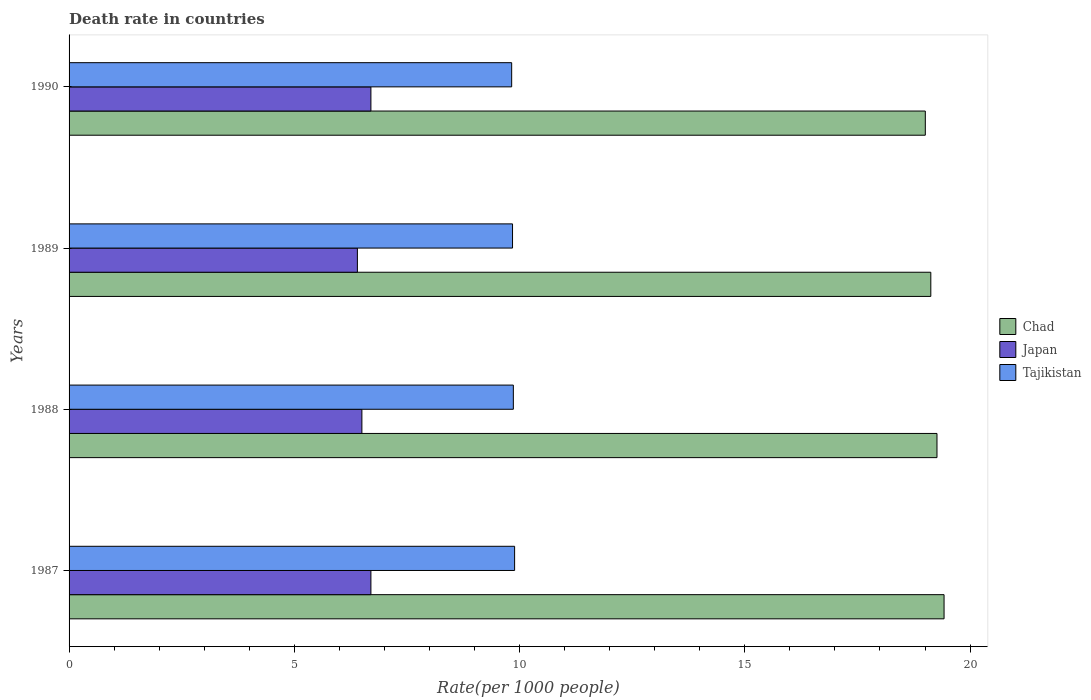How many different coloured bars are there?
Your response must be concise. 3. Are the number of bars on each tick of the Y-axis equal?
Keep it short and to the point. Yes. How many bars are there on the 4th tick from the top?
Make the answer very short. 3. How many bars are there on the 2nd tick from the bottom?
Ensure brevity in your answer.  3. What is the death rate in Tajikistan in 1990?
Make the answer very short. 9.82. Across all years, what is the maximum death rate in Tajikistan?
Your answer should be very brief. 9.89. What is the total death rate in Tajikistan in the graph?
Provide a succinct answer. 39.42. What is the difference between the death rate in Japan in 1988 and that in 1989?
Make the answer very short. 0.1. What is the difference between the death rate in Japan in 1990 and the death rate in Chad in 1989?
Your answer should be very brief. -12.43. What is the average death rate in Japan per year?
Make the answer very short. 6.58. In the year 1988, what is the difference between the death rate in Japan and death rate in Tajikistan?
Ensure brevity in your answer.  -3.36. In how many years, is the death rate in Japan greater than 15 ?
Provide a succinct answer. 0. What is the ratio of the death rate in Japan in 1988 to that in 1990?
Provide a short and direct response. 0.97. Is the difference between the death rate in Japan in 1987 and 1988 greater than the difference between the death rate in Tajikistan in 1987 and 1988?
Your answer should be very brief. Yes. What is the difference between the highest and the second highest death rate in Chad?
Your answer should be compact. 0.16. What is the difference between the highest and the lowest death rate in Tajikistan?
Keep it short and to the point. 0.07. Is the sum of the death rate in Tajikistan in 1987 and 1990 greater than the maximum death rate in Japan across all years?
Provide a short and direct response. Yes. What does the 1st bar from the bottom in 1990 represents?
Provide a succinct answer. Chad. How many bars are there?
Your answer should be compact. 12. Are all the bars in the graph horizontal?
Offer a terse response. Yes. Are the values on the major ticks of X-axis written in scientific E-notation?
Your answer should be compact. No. Does the graph contain any zero values?
Keep it short and to the point. No. Where does the legend appear in the graph?
Your response must be concise. Center right. What is the title of the graph?
Offer a very short reply. Death rate in countries. What is the label or title of the X-axis?
Give a very brief answer. Rate(per 1000 people). What is the Rate(per 1000 people) in Chad in 1987?
Provide a short and direct response. 19.42. What is the Rate(per 1000 people) in Tajikistan in 1987?
Offer a terse response. 9.89. What is the Rate(per 1000 people) of Chad in 1988?
Offer a very short reply. 19.27. What is the Rate(per 1000 people) of Japan in 1988?
Provide a succinct answer. 6.5. What is the Rate(per 1000 people) in Tajikistan in 1988?
Your answer should be compact. 9.86. What is the Rate(per 1000 people) of Chad in 1989?
Provide a short and direct response. 19.13. What is the Rate(per 1000 people) of Tajikistan in 1989?
Your answer should be very brief. 9.84. What is the Rate(per 1000 people) of Chad in 1990?
Make the answer very short. 19.01. What is the Rate(per 1000 people) of Japan in 1990?
Make the answer very short. 6.7. What is the Rate(per 1000 people) of Tajikistan in 1990?
Keep it short and to the point. 9.82. Across all years, what is the maximum Rate(per 1000 people) of Chad?
Offer a terse response. 19.42. Across all years, what is the maximum Rate(per 1000 people) in Japan?
Give a very brief answer. 6.7. Across all years, what is the maximum Rate(per 1000 people) in Tajikistan?
Offer a terse response. 9.89. Across all years, what is the minimum Rate(per 1000 people) in Chad?
Give a very brief answer. 19.01. Across all years, what is the minimum Rate(per 1000 people) in Tajikistan?
Your response must be concise. 9.82. What is the total Rate(per 1000 people) of Chad in the graph?
Keep it short and to the point. 76.83. What is the total Rate(per 1000 people) of Japan in the graph?
Your answer should be compact. 26.3. What is the total Rate(per 1000 people) in Tajikistan in the graph?
Make the answer very short. 39.42. What is the difference between the Rate(per 1000 people) of Chad in 1987 and that in 1988?
Your response must be concise. 0.16. What is the difference between the Rate(per 1000 people) in Tajikistan in 1987 and that in 1988?
Your answer should be very brief. 0.03. What is the difference between the Rate(per 1000 people) in Chad in 1987 and that in 1989?
Offer a very short reply. 0.29. What is the difference between the Rate(per 1000 people) of Japan in 1987 and that in 1989?
Offer a very short reply. 0.3. What is the difference between the Rate(per 1000 people) of Tajikistan in 1987 and that in 1989?
Offer a very short reply. 0.05. What is the difference between the Rate(per 1000 people) in Chad in 1987 and that in 1990?
Offer a terse response. 0.42. What is the difference between the Rate(per 1000 people) in Japan in 1987 and that in 1990?
Ensure brevity in your answer.  0. What is the difference between the Rate(per 1000 people) in Tajikistan in 1987 and that in 1990?
Keep it short and to the point. 0.07. What is the difference between the Rate(per 1000 people) of Chad in 1988 and that in 1989?
Offer a terse response. 0.14. What is the difference between the Rate(per 1000 people) in Japan in 1988 and that in 1989?
Provide a short and direct response. 0.1. What is the difference between the Rate(per 1000 people) in Tajikistan in 1988 and that in 1989?
Keep it short and to the point. 0.02. What is the difference between the Rate(per 1000 people) of Chad in 1988 and that in 1990?
Give a very brief answer. 0.26. What is the difference between the Rate(per 1000 people) in Tajikistan in 1988 and that in 1990?
Give a very brief answer. 0.04. What is the difference between the Rate(per 1000 people) in Chad in 1989 and that in 1990?
Your answer should be very brief. 0.12. What is the difference between the Rate(per 1000 people) in Tajikistan in 1989 and that in 1990?
Provide a short and direct response. 0.02. What is the difference between the Rate(per 1000 people) in Chad in 1987 and the Rate(per 1000 people) in Japan in 1988?
Offer a very short reply. 12.92. What is the difference between the Rate(per 1000 people) of Chad in 1987 and the Rate(per 1000 people) of Tajikistan in 1988?
Make the answer very short. 9.56. What is the difference between the Rate(per 1000 people) in Japan in 1987 and the Rate(per 1000 people) in Tajikistan in 1988?
Your answer should be compact. -3.16. What is the difference between the Rate(per 1000 people) in Chad in 1987 and the Rate(per 1000 people) in Japan in 1989?
Provide a short and direct response. 13.02. What is the difference between the Rate(per 1000 people) in Chad in 1987 and the Rate(per 1000 people) in Tajikistan in 1989?
Your answer should be compact. 9.58. What is the difference between the Rate(per 1000 people) of Japan in 1987 and the Rate(per 1000 people) of Tajikistan in 1989?
Keep it short and to the point. -3.14. What is the difference between the Rate(per 1000 people) in Chad in 1987 and the Rate(per 1000 people) in Japan in 1990?
Offer a very short reply. 12.72. What is the difference between the Rate(per 1000 people) of Chad in 1987 and the Rate(per 1000 people) of Tajikistan in 1990?
Your answer should be very brief. 9.6. What is the difference between the Rate(per 1000 people) of Japan in 1987 and the Rate(per 1000 people) of Tajikistan in 1990?
Provide a short and direct response. -3.12. What is the difference between the Rate(per 1000 people) of Chad in 1988 and the Rate(per 1000 people) of Japan in 1989?
Provide a short and direct response. 12.87. What is the difference between the Rate(per 1000 people) of Chad in 1988 and the Rate(per 1000 people) of Tajikistan in 1989?
Provide a short and direct response. 9.42. What is the difference between the Rate(per 1000 people) of Japan in 1988 and the Rate(per 1000 people) of Tajikistan in 1989?
Make the answer very short. -3.34. What is the difference between the Rate(per 1000 people) of Chad in 1988 and the Rate(per 1000 people) of Japan in 1990?
Provide a succinct answer. 12.57. What is the difference between the Rate(per 1000 people) in Chad in 1988 and the Rate(per 1000 people) in Tajikistan in 1990?
Offer a very short reply. 9.44. What is the difference between the Rate(per 1000 people) in Japan in 1988 and the Rate(per 1000 people) in Tajikistan in 1990?
Make the answer very short. -3.33. What is the difference between the Rate(per 1000 people) of Chad in 1989 and the Rate(per 1000 people) of Japan in 1990?
Your answer should be compact. 12.43. What is the difference between the Rate(per 1000 people) of Chad in 1989 and the Rate(per 1000 people) of Tajikistan in 1990?
Offer a very short reply. 9.3. What is the difference between the Rate(per 1000 people) of Japan in 1989 and the Rate(per 1000 people) of Tajikistan in 1990?
Provide a succinct answer. -3.42. What is the average Rate(per 1000 people) of Chad per year?
Provide a succinct answer. 19.21. What is the average Rate(per 1000 people) in Japan per year?
Keep it short and to the point. 6.58. What is the average Rate(per 1000 people) of Tajikistan per year?
Ensure brevity in your answer.  9.86. In the year 1987, what is the difference between the Rate(per 1000 people) of Chad and Rate(per 1000 people) of Japan?
Offer a terse response. 12.72. In the year 1987, what is the difference between the Rate(per 1000 people) in Chad and Rate(per 1000 people) in Tajikistan?
Offer a terse response. 9.53. In the year 1987, what is the difference between the Rate(per 1000 people) of Japan and Rate(per 1000 people) of Tajikistan?
Make the answer very short. -3.19. In the year 1988, what is the difference between the Rate(per 1000 people) in Chad and Rate(per 1000 people) in Japan?
Make the answer very short. 12.77. In the year 1988, what is the difference between the Rate(per 1000 people) in Chad and Rate(per 1000 people) in Tajikistan?
Give a very brief answer. 9.4. In the year 1988, what is the difference between the Rate(per 1000 people) of Japan and Rate(per 1000 people) of Tajikistan?
Provide a succinct answer. -3.36. In the year 1989, what is the difference between the Rate(per 1000 people) in Chad and Rate(per 1000 people) in Japan?
Make the answer very short. 12.73. In the year 1989, what is the difference between the Rate(per 1000 people) of Chad and Rate(per 1000 people) of Tajikistan?
Keep it short and to the point. 9.29. In the year 1989, what is the difference between the Rate(per 1000 people) of Japan and Rate(per 1000 people) of Tajikistan?
Your response must be concise. -3.44. In the year 1990, what is the difference between the Rate(per 1000 people) in Chad and Rate(per 1000 people) in Japan?
Your response must be concise. 12.31. In the year 1990, what is the difference between the Rate(per 1000 people) of Chad and Rate(per 1000 people) of Tajikistan?
Provide a short and direct response. 9.18. In the year 1990, what is the difference between the Rate(per 1000 people) in Japan and Rate(per 1000 people) in Tajikistan?
Your response must be concise. -3.12. What is the ratio of the Rate(per 1000 people) of Japan in 1987 to that in 1988?
Your answer should be very brief. 1.03. What is the ratio of the Rate(per 1000 people) of Chad in 1987 to that in 1989?
Offer a terse response. 1.02. What is the ratio of the Rate(per 1000 people) in Japan in 1987 to that in 1989?
Your answer should be compact. 1.05. What is the ratio of the Rate(per 1000 people) in Chad in 1987 to that in 1990?
Offer a very short reply. 1.02. What is the ratio of the Rate(per 1000 people) of Japan in 1987 to that in 1990?
Provide a short and direct response. 1. What is the ratio of the Rate(per 1000 people) in Tajikistan in 1987 to that in 1990?
Provide a succinct answer. 1.01. What is the ratio of the Rate(per 1000 people) of Chad in 1988 to that in 1989?
Your answer should be compact. 1.01. What is the ratio of the Rate(per 1000 people) in Japan in 1988 to that in 1989?
Your answer should be compact. 1.02. What is the ratio of the Rate(per 1000 people) of Chad in 1988 to that in 1990?
Keep it short and to the point. 1.01. What is the ratio of the Rate(per 1000 people) in Japan in 1988 to that in 1990?
Your response must be concise. 0.97. What is the ratio of the Rate(per 1000 people) of Tajikistan in 1988 to that in 1990?
Your answer should be very brief. 1. What is the ratio of the Rate(per 1000 people) in Chad in 1989 to that in 1990?
Ensure brevity in your answer.  1.01. What is the ratio of the Rate(per 1000 people) in Japan in 1989 to that in 1990?
Offer a terse response. 0.96. What is the difference between the highest and the second highest Rate(per 1000 people) in Chad?
Offer a very short reply. 0.16. What is the difference between the highest and the second highest Rate(per 1000 people) of Tajikistan?
Make the answer very short. 0.03. What is the difference between the highest and the lowest Rate(per 1000 people) in Chad?
Keep it short and to the point. 0.42. What is the difference between the highest and the lowest Rate(per 1000 people) of Japan?
Give a very brief answer. 0.3. What is the difference between the highest and the lowest Rate(per 1000 people) of Tajikistan?
Keep it short and to the point. 0.07. 